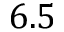Convert formula to latex. <formula><loc_0><loc_0><loc_500><loc_500>6 . 5</formula> 